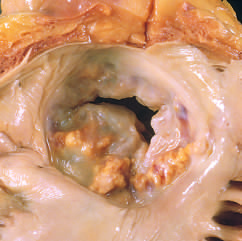one cusp has a partial fusion at whose center?
Answer the question using a single word or phrase. Its 